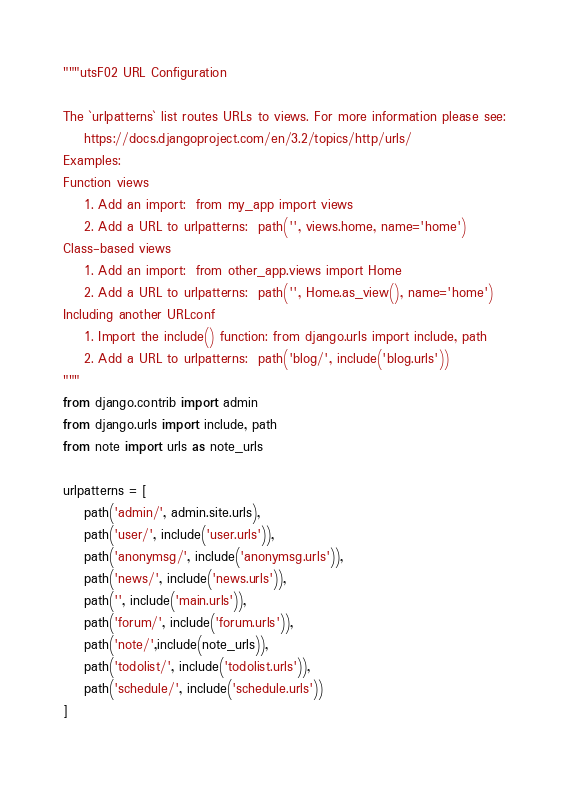Convert code to text. <code><loc_0><loc_0><loc_500><loc_500><_Python_>"""utsF02 URL Configuration

The `urlpatterns` list routes URLs to views. For more information please see:
    https://docs.djangoproject.com/en/3.2/topics/http/urls/
Examples:
Function views
    1. Add an import:  from my_app import views
    2. Add a URL to urlpatterns:  path('', views.home, name='home')
Class-based views
    1. Add an import:  from other_app.views import Home
    2. Add a URL to urlpatterns:  path('', Home.as_view(), name='home')
Including another URLconf
    1. Import the include() function: from django.urls import include, path
    2. Add a URL to urlpatterns:  path('blog/', include('blog.urls'))
"""
from django.contrib import admin
from django.urls import include, path
from note import urls as note_urls

urlpatterns = [
    path('admin/', admin.site.urls),
    path('user/', include('user.urls')),
    path('anonymsg/', include('anonymsg.urls')),
    path('news/', include('news.urls')),
    path('', include('main.urls')),
    path('forum/', include('forum.urls')),
    path('note/',include(note_urls)),
    path('todolist/', include('todolist.urls')),
    path('schedule/', include('schedule.urls'))
]
</code> 